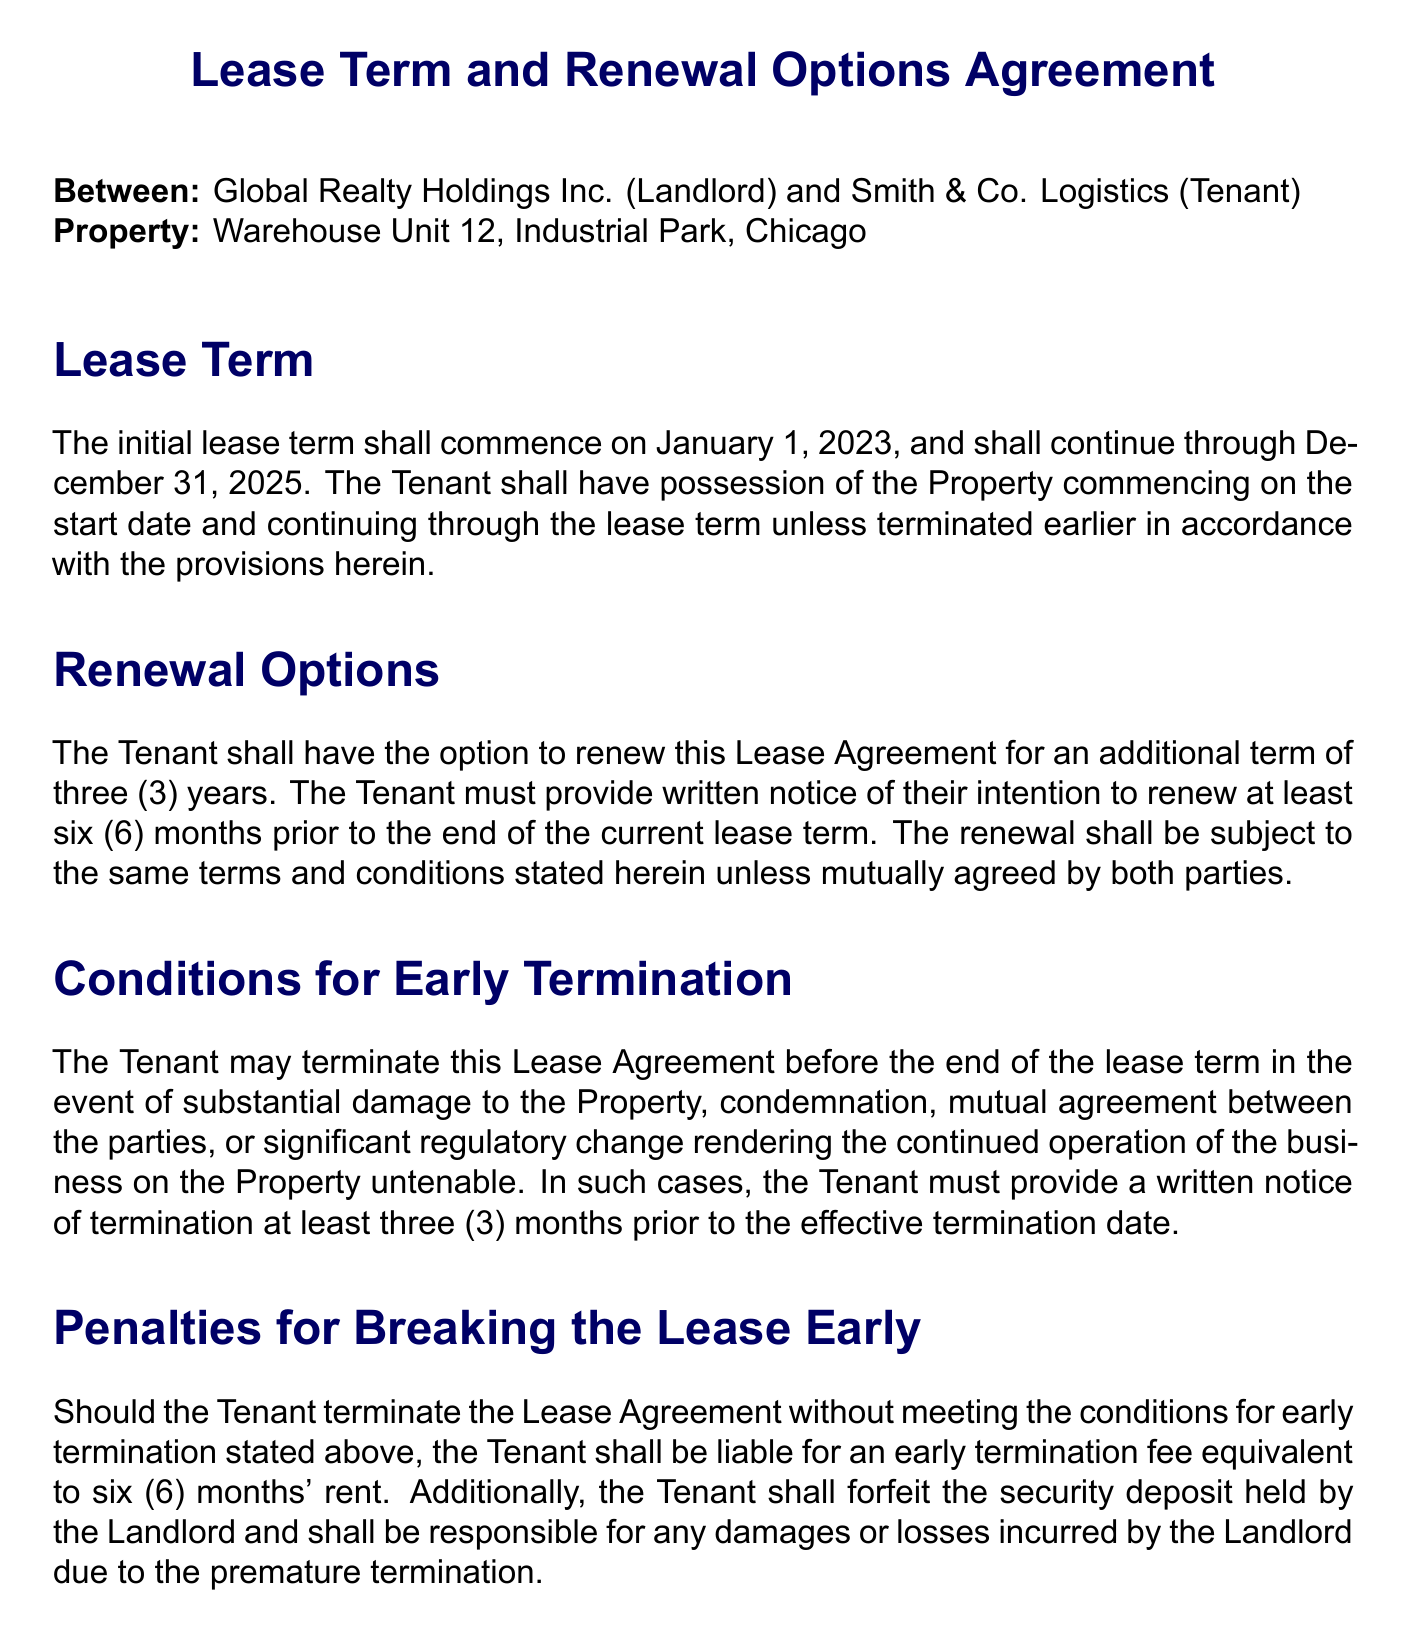What is the initial lease term start date? The start date of the lease term can be found in the 'Lease Term' section, which states it begins on January 1, 2023.
Answer: January 1, 2023 What is the duration of the renewal option? The renewal option is mentioned as an additional term of three years, specified in the 'Renewal Options' section.
Answer: three (3) years How much notice must the Tenant give for renewal? The notice period for renewal is indicated as six months before the current lease term ends, outlined in the 'Renewal Options' section.
Answer: six (6) months What is the penalty for early termination without conditions? The penalty for breaking the lease early, if the conditions are not met, is specified as six months' rent in the 'Penalties for Breaking the Lease Early' section.
Answer: six (6) months' rent What conditions allow the Tenant to terminate the Lease early? The conditions for early termination include substantial damage, condemnation, mutual agreement, or significant regulatory change, listed in the 'Conditions for Early Termination' section.
Answer: substantial damage, condemnation, mutual agreement, significant regulatory change What is the deadline for written notice of early termination? The deadline for providing written notice before early termination must be three months, as stated in the 'Conditions for Early Termination' section.
Answer: three (3) months Who are the parties involved in this Lease Agreement? The parties involved in the agreement are identified at the beginning of the document as Global Realty Holdings Inc. (Landlord) and Smith & Co. Logistics (Tenant).
Answer: Global Realty Holdings Inc. and Smith & Co. Logistics 